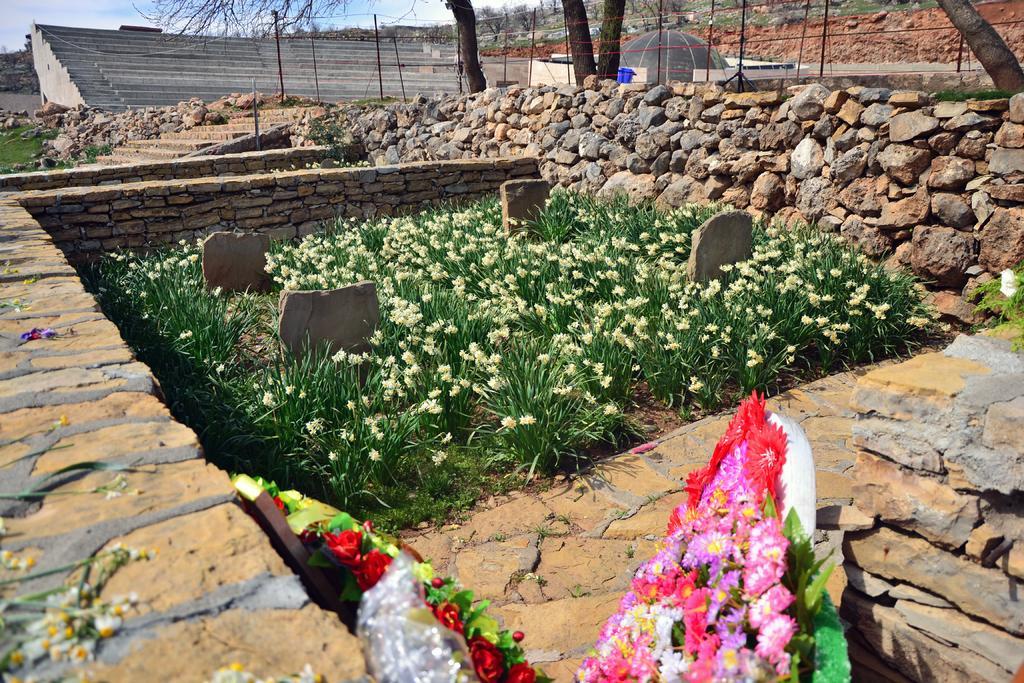Can you describe this image briefly? In this image there is a field. There are some flower plants. There is a boundary to it. In the foreground there is a board on it there are many flowers are there. There is fence around the field. This is looking like a gallery.. There are trees. The wall is made up of stones. There are stairs. 